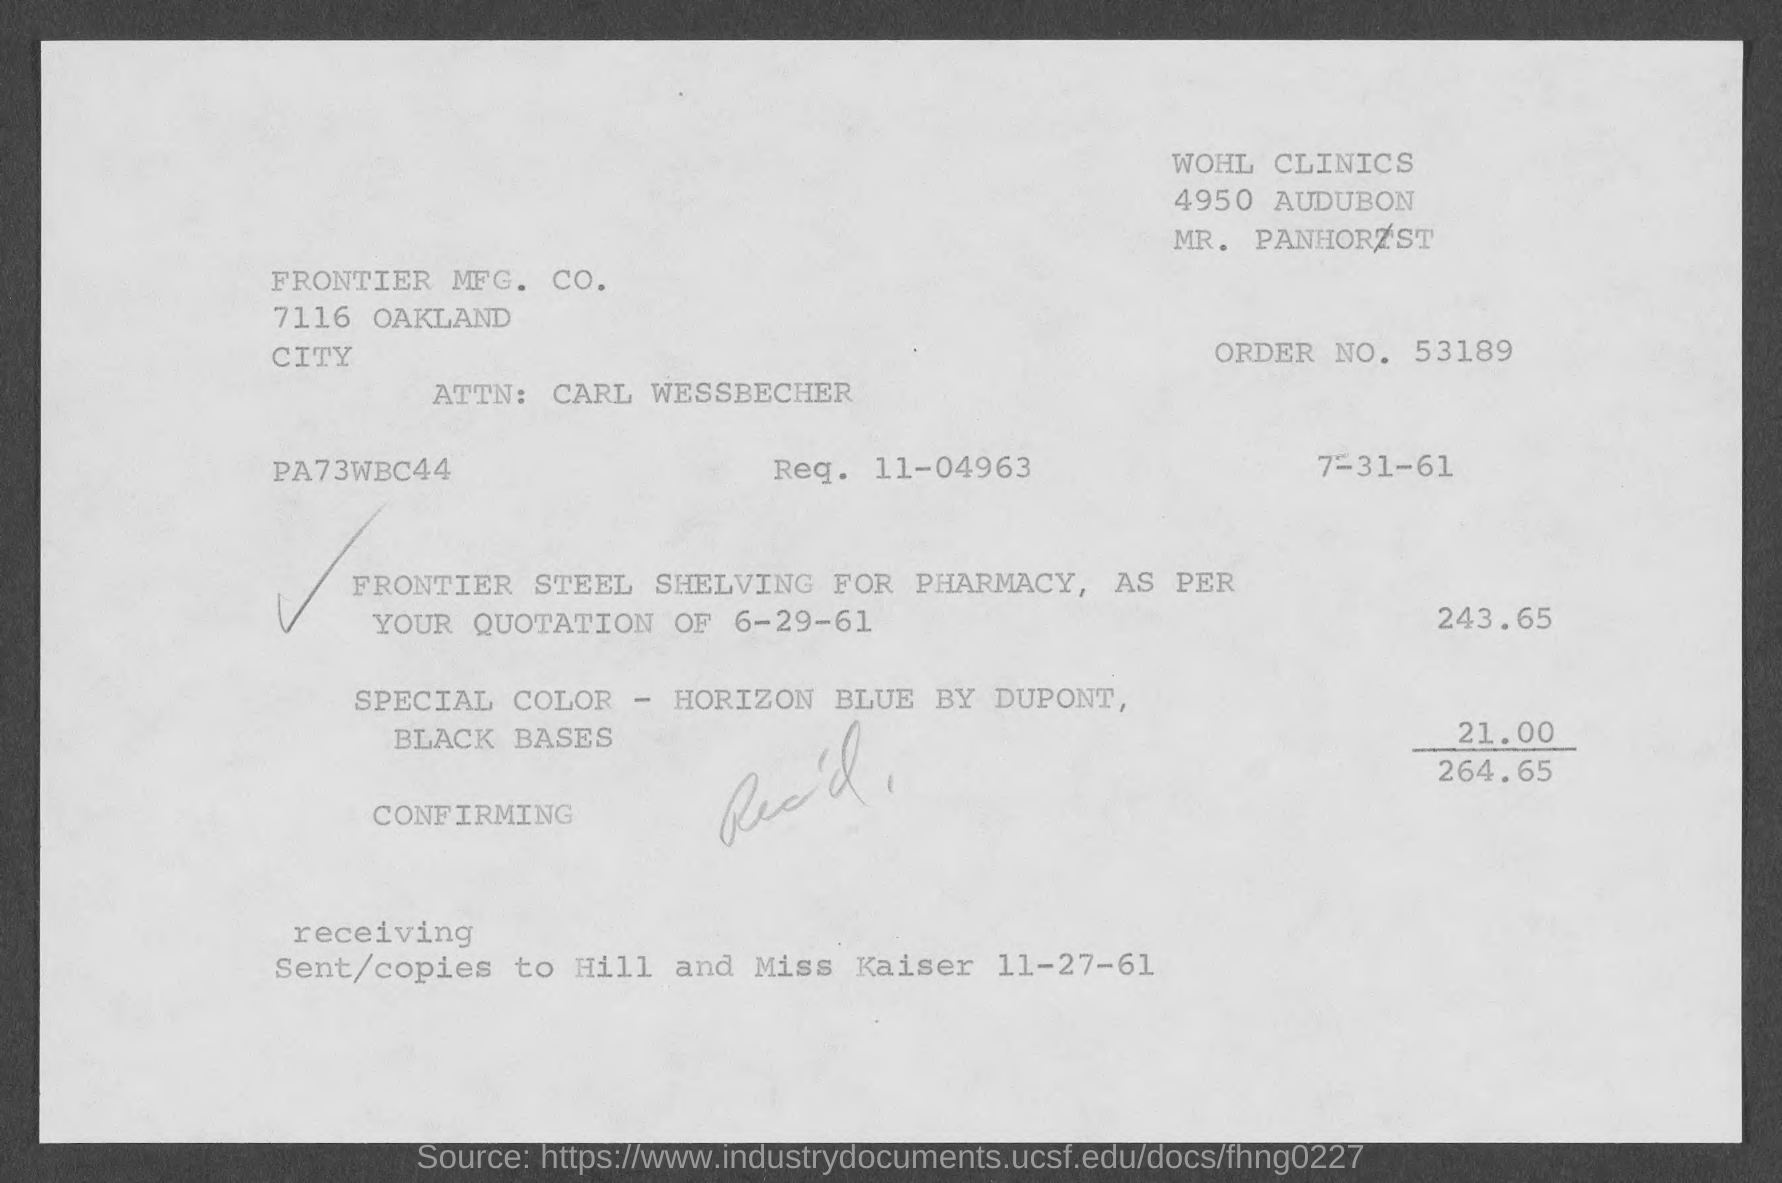What is the order no.?
Keep it short and to the point. 53189. 